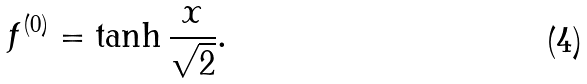Convert formula to latex. <formula><loc_0><loc_0><loc_500><loc_500>f ^ { ( 0 ) } = \tanh \frac { x } { \sqrt { 2 } } .</formula> 